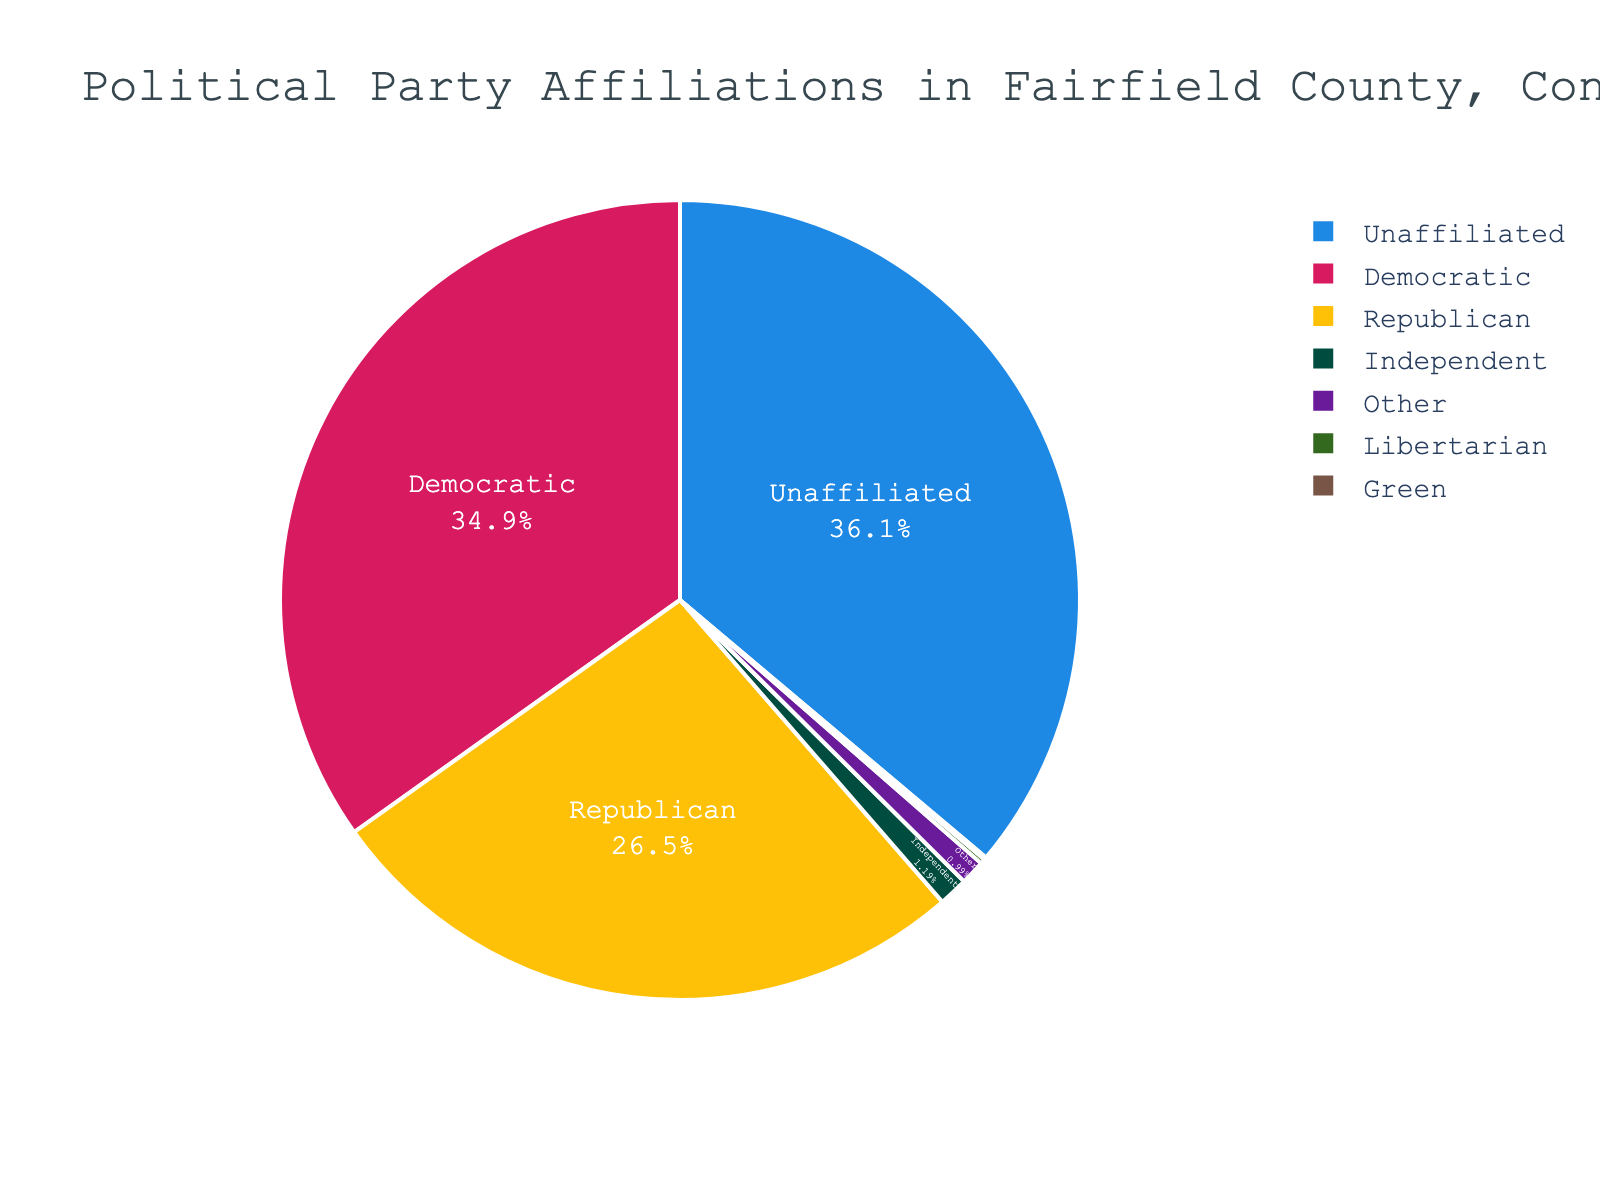What percentage of people are unaffiliated? To find the percentage of unaffiliated people, look at the pie chart segment labeled "Unaffiliated." The figure shows the percentage directly.
Answer: 36.5% Which party has the smallest representation? Observe all segments in the pie chart and compare their sizes. The segment labeled "Green" will be the smallest.
Answer: Green What is the combined percentage of Republican and Democratic affiliations? Add the percentages of the Republican and Democratic parties. According to the figure, they are 26.8% and 35.2% respectively. So, 26.8 + 35.2 = 62.0.
Answer: 62.0% Is the percentage of Independent affiliations greater than that of Libertarian and Green affiliations combined? Compare the percentage of Independent affiliations (1.2%) with the sum of Libertarian (0.2%) and Green (0.1%) affiliations. Calculate the total for Libertarian and Green: 0.2 + 0.1 = 0.3. 1.2% > 0.3%.
Answer: Yes What is the percentage difference between Unaffiliated and Republican affiliations? Find the percentage of Unaffiliated and Republican from the chart: 36.5% for Unaffiliated and 26.8% for Republican. Subtract the two values: 36.5 - 26.8 = 9.7.
Answer: 9.7% Are there more unaffiliated people than the combined total of Independent, Libertarian, and Other affiliations? Compare the unaffiliated percentage (36.5%) with the sum of Independent (1.2%), Libertarian (0.2%), and Other (1.0%) affiliations. Calculate the total: 1.2 + 0.2 + 1.0 = 2.4. 36.5% > 2.4%.
Answer: Yes Which segment is visually represented with blue? Identify the blue segment in the pie chart. The segment labeled "Democratic" is colored blue.
Answer: Democratic What percentage of people are affiliated with third parties (Independent, Libertarian, Green, Other combined)? Add the percentages of Independent, Libertarian, Green, and Other from the chart: 1.2 + 0.2 + 0.1 + 1.0 = 2.5.
Answer: 2.5% Is the proportion of Democratic affiliations almost the same as that of Unaffiliated affiliations? Compare the percentages of Democratic (35.2%) and Unaffiliated (36.5%). Although close, they are not the same, but they are relatively similar in proportion.
Answer: Yes, nearly the same How much more in percentage are Democrats compared to Libertarians? Subtract the Libertarian percentage (0.2%) from the Democratic percentage (35.2%): 35.2 - 0.2 = 35.0.
Answer: 35.0% 